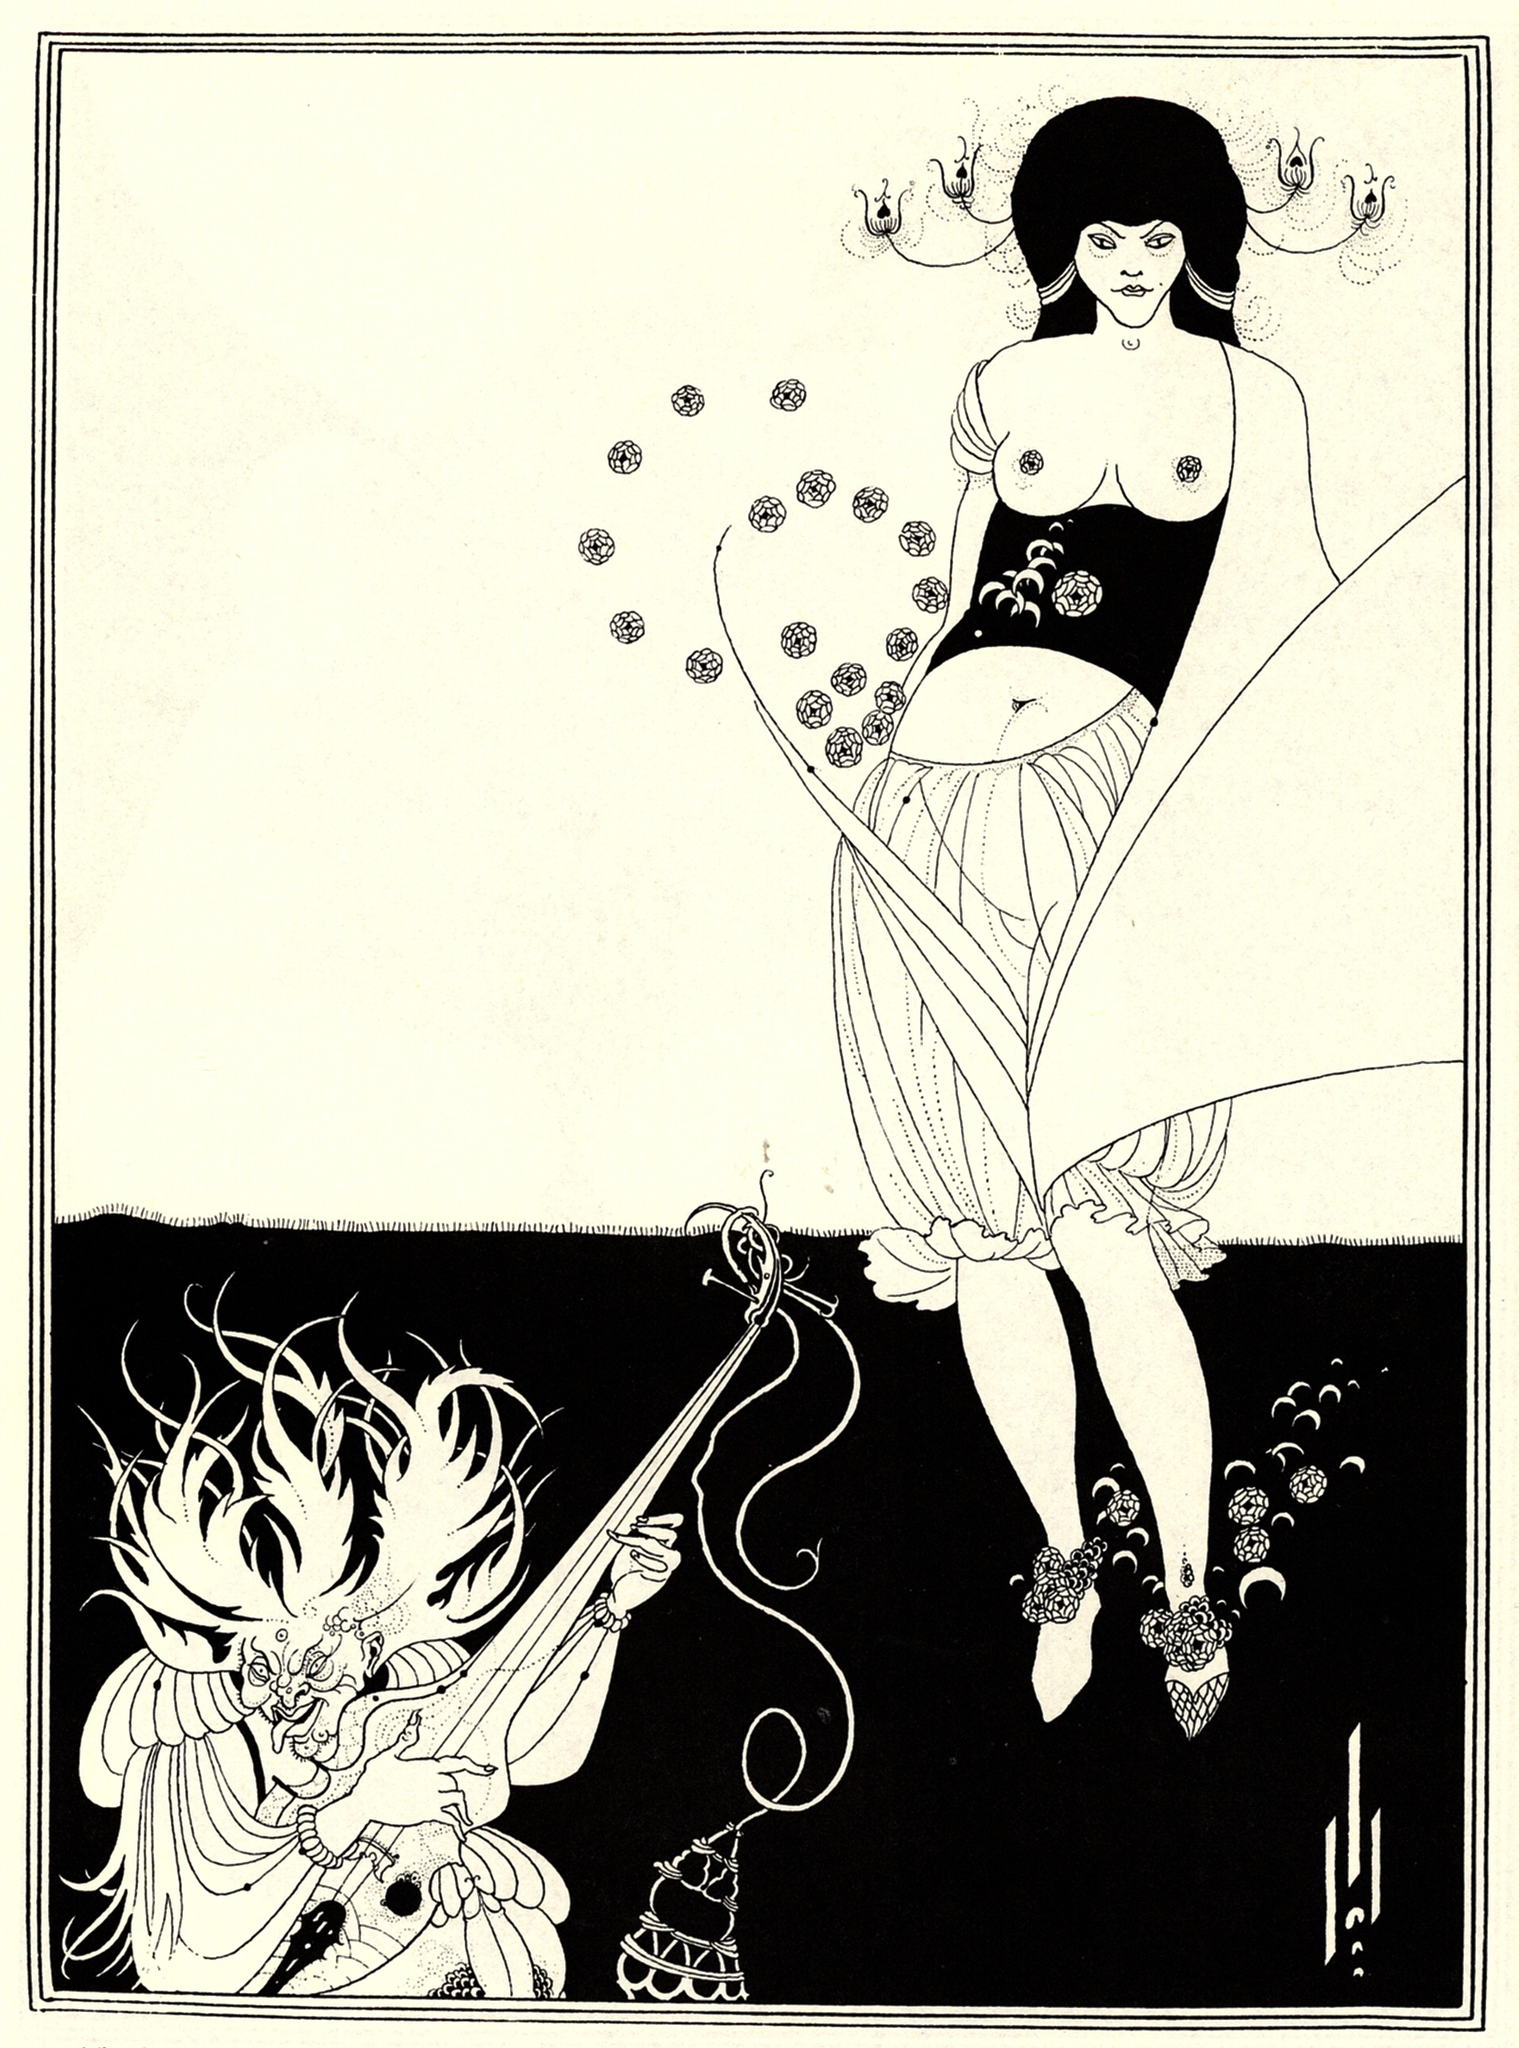Imagine a world where every element in the image has magical powers. Describe how the characters would interact in such a world. In a magical world, every detail in the scene would be imbued with fantastical properties. The floral patterns on the woman's dress could blossom into living flowers, granting her the ability to commune with nature and harness its energies for healing or enchantments. Her wand might channel forces of light, casting powerful spells of protection or transformation.

The dragon’s censer could emit enchanted smoke that reveals truths or conjures illusions, while its sword blazes with fiery runes capable of cutting through any barrier, both physical and mystical. In such a world, the interactions between the woman and the dragon would be a mesmerizing ballet of magical prowess, each spell and counterspell merging natural and supernatural forces. Their battle would be a glorified dance, filled with spectacular displays of magic, where every action carries the weight of ancient lore and sorcery, culminating in a grand spectacle where the balance between might and magic is both challenged and exalted. 